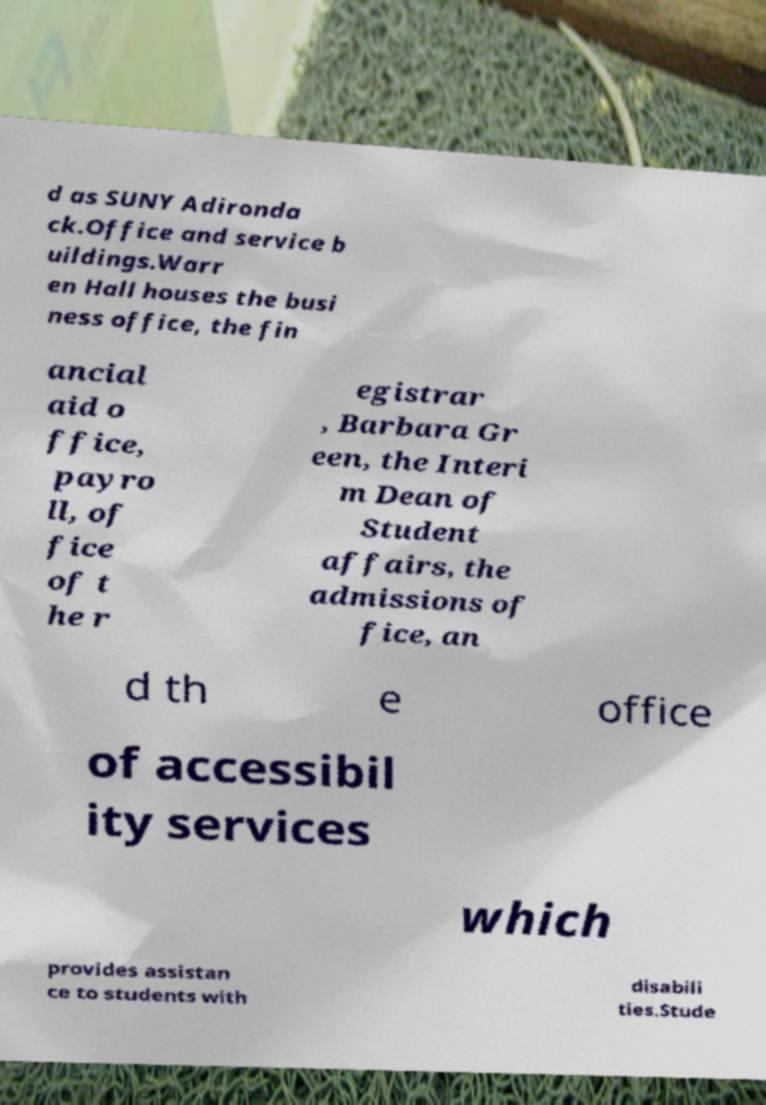Could you extract and type out the text from this image? d as SUNY Adironda ck.Office and service b uildings.Warr en Hall houses the busi ness office, the fin ancial aid o ffice, payro ll, of fice of t he r egistrar , Barbara Gr een, the Interi m Dean of Student affairs, the admissions of fice, an d th e office of accessibil ity services which provides assistan ce to students with disabili ties.Stude 